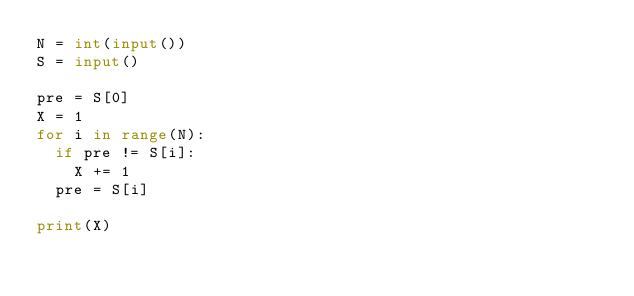<code> <loc_0><loc_0><loc_500><loc_500><_Python_>N = int(input())
S = input()

pre = S[0]
X = 1
for i in range(N):
  if pre != S[i]:
    X += 1
  pre = S[i]

print(X)</code> 